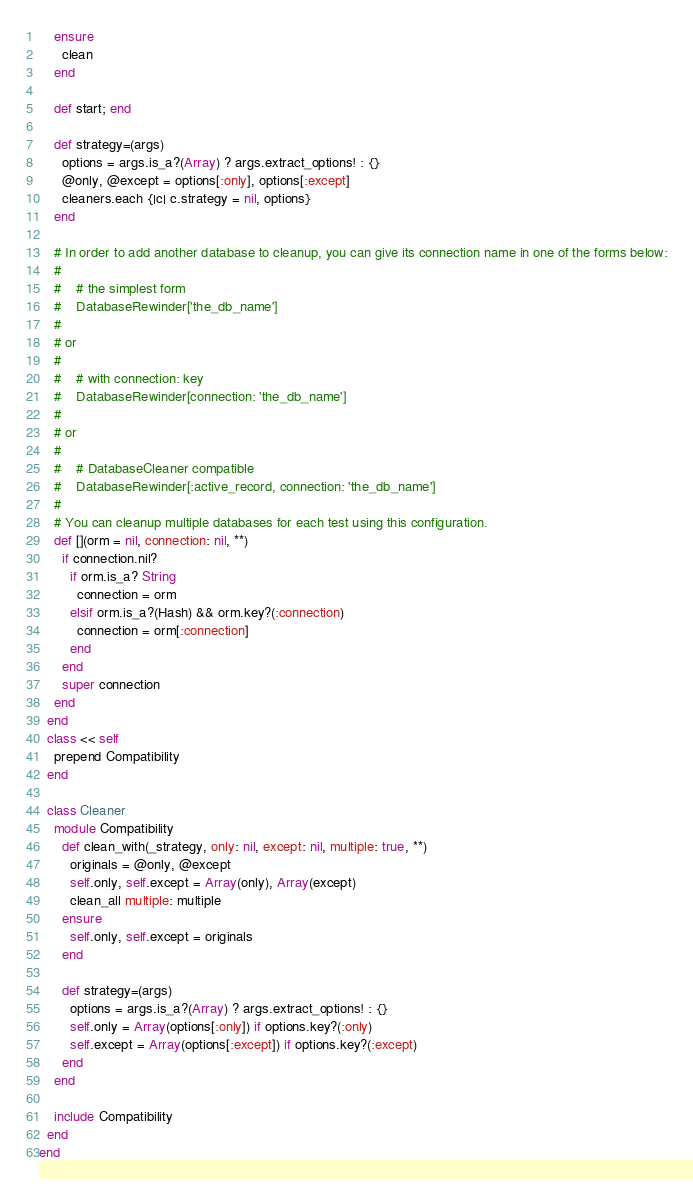<code> <loc_0><loc_0><loc_500><loc_500><_Ruby_>    ensure
      clean
    end

    def start; end

    def strategy=(args)
      options = args.is_a?(Array) ? args.extract_options! : {}
      @only, @except = options[:only], options[:except]
      cleaners.each {|c| c.strategy = nil, options}
    end

    # In order to add another database to cleanup, you can give its connection name in one of the forms below:
    #
    #    # the simplest form
    #    DatabaseRewinder['the_db_name']
    #
    # or
    #
    #    # with connection: key
    #    DatabaseRewinder[connection: 'the_db_name']
    #
    # or
    #
    #    # DatabaseCleaner compatible
    #    DatabaseRewinder[:active_record, connection: 'the_db_name']
    #
    # You can cleanup multiple databases for each test using this configuration.
    def [](orm = nil, connection: nil, **)
      if connection.nil?
        if orm.is_a? String
          connection = orm
        elsif orm.is_a?(Hash) && orm.key?(:connection)
          connection = orm[:connection]
        end
      end
      super connection
    end
  end
  class << self
    prepend Compatibility
  end

  class Cleaner
    module Compatibility
      def clean_with(_strategy, only: nil, except: nil, multiple: true, **)
        originals = @only, @except
        self.only, self.except = Array(only), Array(except)
        clean_all multiple: multiple
      ensure
        self.only, self.except = originals
      end

      def strategy=(args)
        options = args.is_a?(Array) ? args.extract_options! : {}
        self.only = Array(options[:only]) if options.key?(:only)
        self.except = Array(options[:except]) if options.key?(:except)
      end
    end

    include Compatibility
  end
end
</code> 